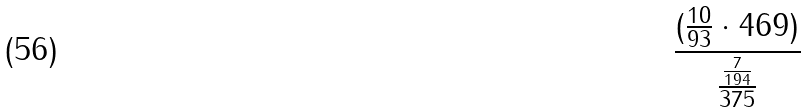<formula> <loc_0><loc_0><loc_500><loc_500>\frac { ( \frac { 1 0 } { 9 3 } \cdot 4 6 9 ) } { \frac { \frac { 7 } { 1 9 4 } } { 3 7 5 } }</formula> 